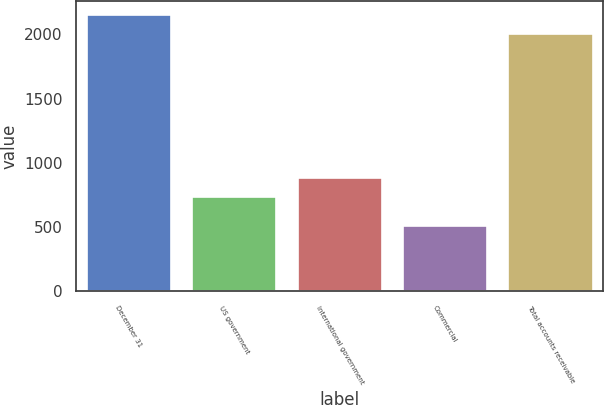Convert chart to OTSL. <chart><loc_0><loc_0><loc_500><loc_500><bar_chart><fcel>December 31<fcel>US government<fcel>International government<fcel>Commercial<fcel>Total accounts receivable<nl><fcel>2153.4<fcel>736<fcel>885.4<fcel>511<fcel>2004<nl></chart> 